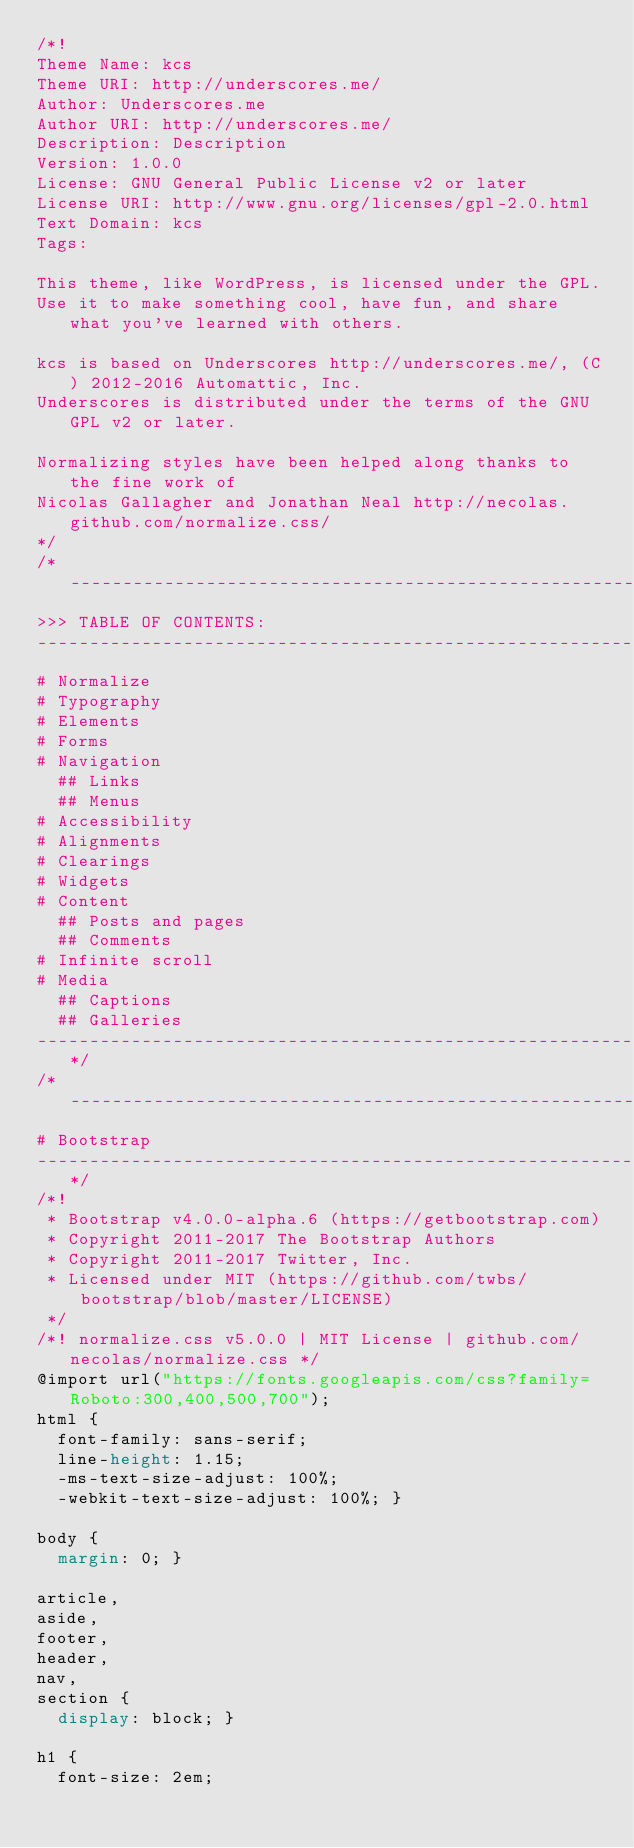<code> <loc_0><loc_0><loc_500><loc_500><_CSS_>/*!
Theme Name: kcs
Theme URI: http://underscores.me/
Author: Underscores.me
Author URI: http://underscores.me/
Description: Description
Version: 1.0.0
License: GNU General Public License v2 or later
License URI: http://www.gnu.org/licenses/gpl-2.0.html
Text Domain: kcs
Tags:

This theme, like WordPress, is licensed under the GPL.
Use it to make something cool, have fun, and share what you've learned with others.

kcs is based on Underscores http://underscores.me/, (C) 2012-2016 Automattic, Inc.
Underscores is distributed under the terms of the GNU GPL v2 or later.

Normalizing styles have been helped along thanks to the fine work of
Nicolas Gallagher and Jonathan Neal http://necolas.github.com/normalize.css/
*/
/*--------------------------------------------------------------
>>> TABLE OF CONTENTS:
----------------------------------------------------------------
# Normalize
# Typography
# Elements
# Forms
# Navigation
	## Links
	## Menus
# Accessibility
# Alignments
# Clearings
# Widgets
# Content
	## Posts and pages
	## Comments
# Infinite scroll
# Media
	## Captions
	## Galleries
--------------------------------------------------------------*/
/*--------------------------------------------------------------
# Bootstrap
--------------------------------------------------------------*/
/*!
 * Bootstrap v4.0.0-alpha.6 (https://getbootstrap.com)
 * Copyright 2011-2017 The Bootstrap Authors
 * Copyright 2011-2017 Twitter, Inc.
 * Licensed under MIT (https://github.com/twbs/bootstrap/blob/master/LICENSE)
 */
/*! normalize.css v5.0.0 | MIT License | github.com/necolas/normalize.css */
@import url("https://fonts.googleapis.com/css?family=Roboto:300,400,500,700");
html {
  font-family: sans-serif;
  line-height: 1.15;
  -ms-text-size-adjust: 100%;
  -webkit-text-size-adjust: 100%; }

body {
  margin: 0; }

article,
aside,
footer,
header,
nav,
section {
  display: block; }

h1 {
  font-size: 2em;</code> 